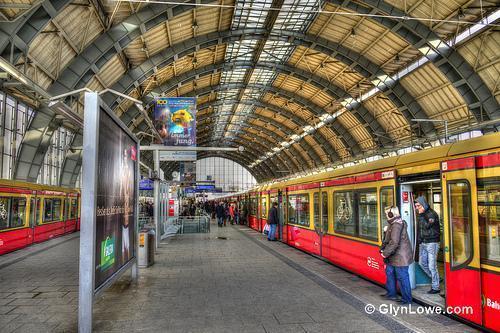How many trains are there?
Give a very brief answer. 2. 